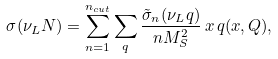Convert formula to latex. <formula><loc_0><loc_0><loc_500><loc_500>\sigma ( \nu _ { L } N ) = \sum _ { n = 1 } ^ { n _ { c u t } } \sum _ { q } { \frac { \tilde { \sigma } _ { n } ( \nu _ { L } q ) } { n M _ { S } ^ { 2 } } } \, x \, q ( x , Q ) ,</formula> 